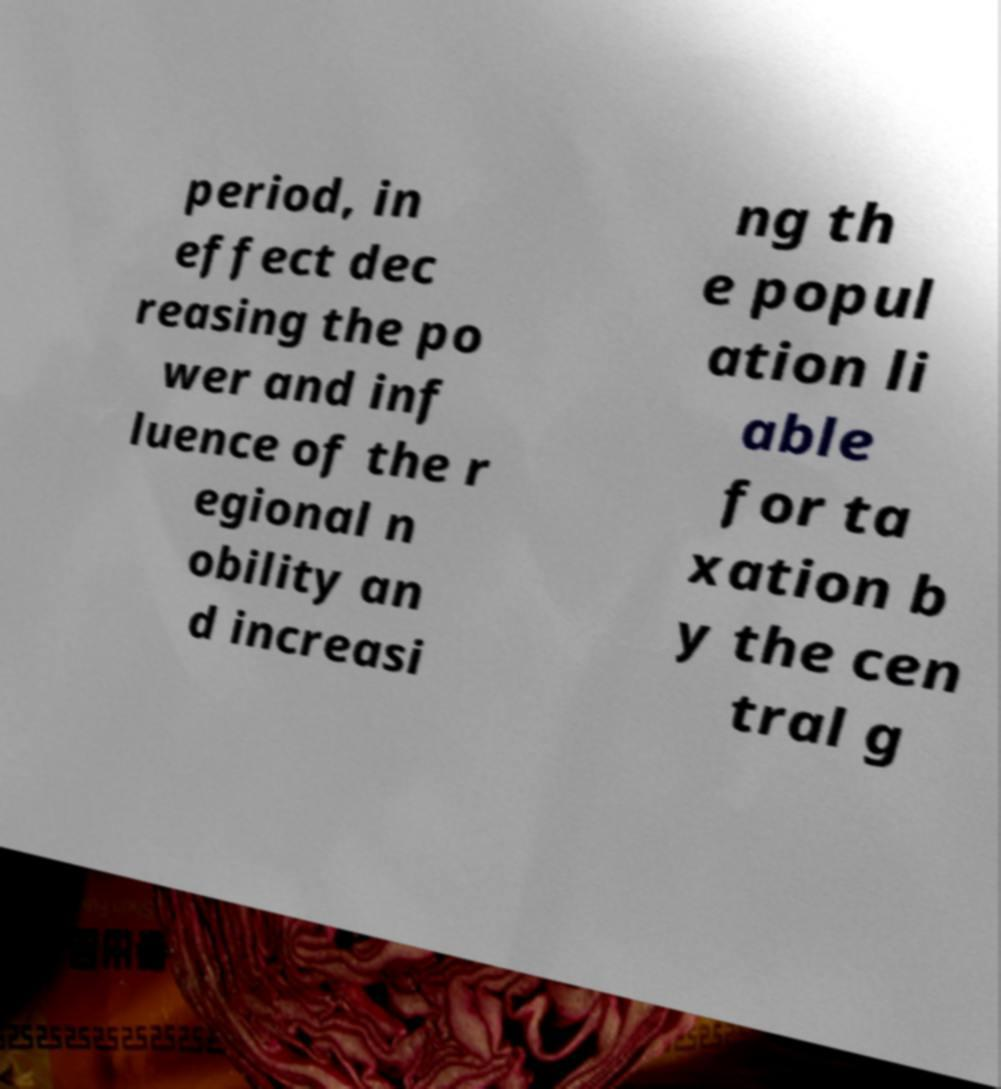There's text embedded in this image that I need extracted. Can you transcribe it verbatim? period, in effect dec reasing the po wer and inf luence of the r egional n obility an d increasi ng th e popul ation li able for ta xation b y the cen tral g 